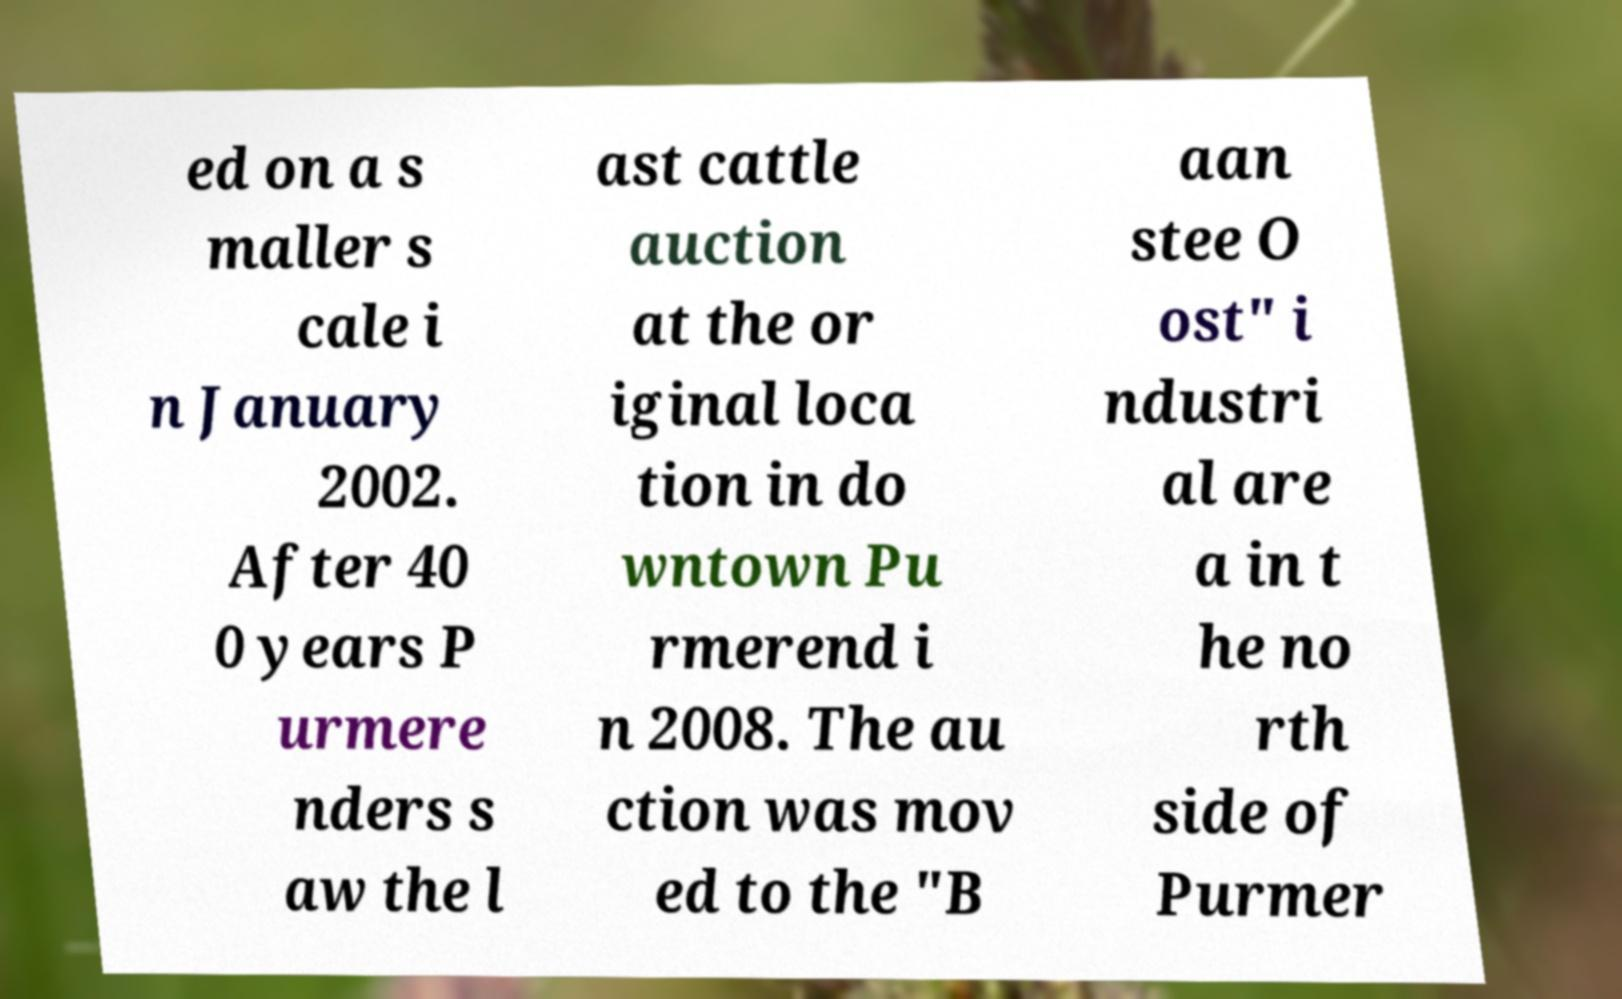Please read and relay the text visible in this image. What does it say? ed on a s maller s cale i n January 2002. After 40 0 years P urmere nders s aw the l ast cattle auction at the or iginal loca tion in do wntown Pu rmerend i n 2008. The au ction was mov ed to the "B aan stee O ost" i ndustri al are a in t he no rth side of Purmer 